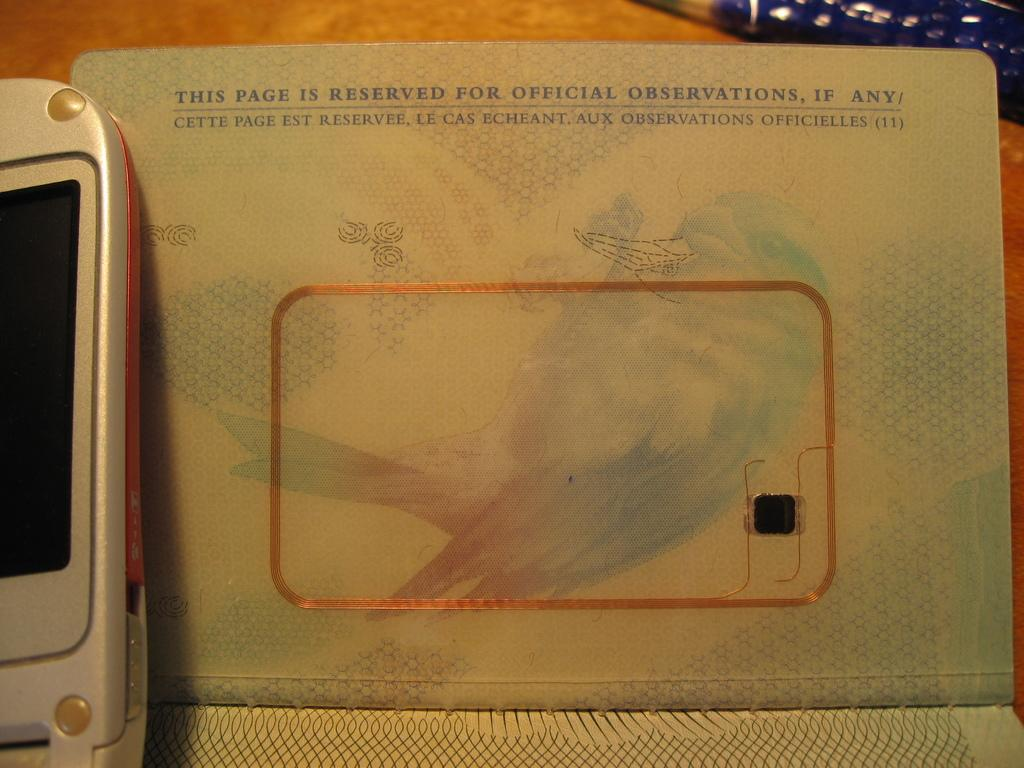Provide a one-sentence caption for the provided image. A passport is opened to a page that says "This page is reserved for official observations, if any". 